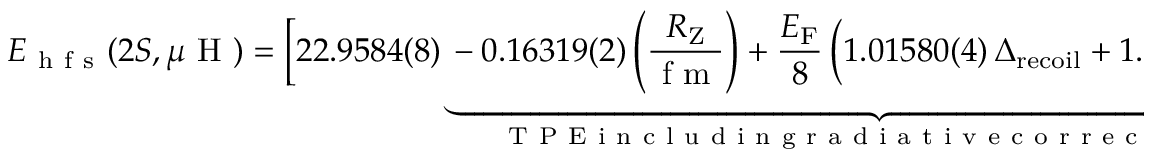<formula> <loc_0><loc_0><loc_500><loc_500>E _ { h f s } ( 2 S , \mu H ) = \left [ 2 2 . 9 5 8 4 ( 8 ) \underbrace { - 0 . 1 6 3 1 9 ( 2 ) \left ( \frac { R _ { Z } } { f m } \right ) + \frac { E _ { F } } { 8 } \, \left ( 1 . 0 1 5 8 0 ( 4 ) \, \Delta _ { r e c o i l } + 1 . 0 0 3 2 6 \, \Delta _ { p o l . } \right ) } _ { T P E i n c l u d i n g r a d i a t i v e c o r r e c t i o n s } \right ] \, m e V ,</formula> 